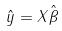Convert formula to latex. <formula><loc_0><loc_0><loc_500><loc_500>\hat { y } = X \hat { \beta }</formula> 